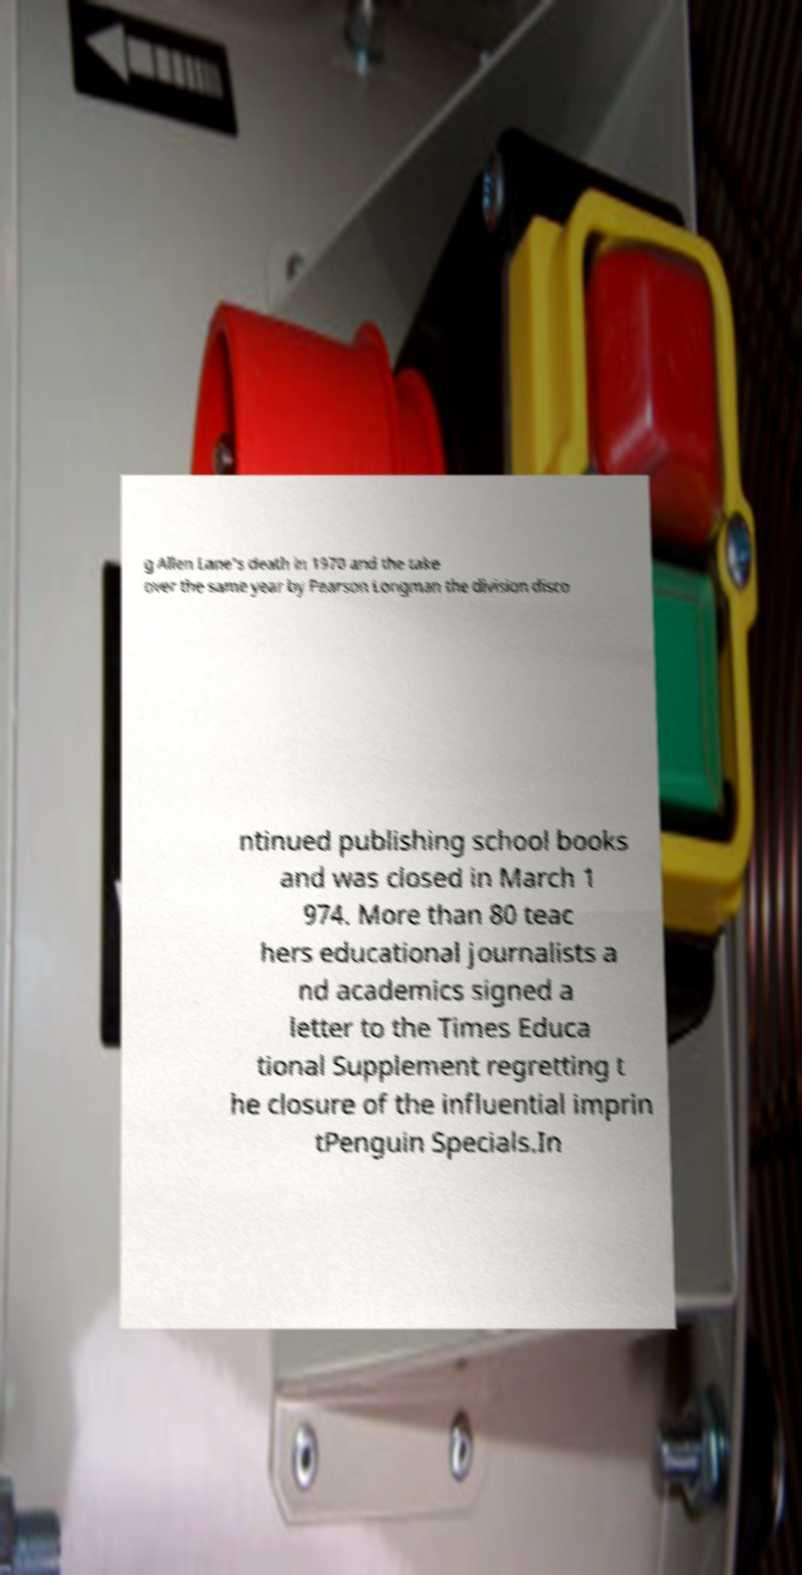For documentation purposes, I need the text within this image transcribed. Could you provide that? g Allen Lane's death in 1970 and the take over the same year by Pearson Longman the division disco ntinued publishing school books and was closed in March 1 974. More than 80 teac hers educational journalists a nd academics signed a letter to the Times Educa tional Supplement regretting t he closure of the influential imprin tPenguin Specials.In 